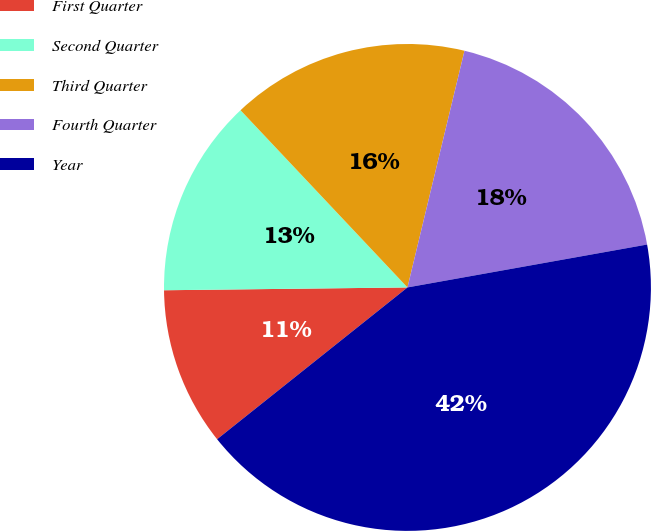<chart> <loc_0><loc_0><loc_500><loc_500><pie_chart><fcel>First Quarter<fcel>Second Quarter<fcel>Third Quarter<fcel>Fourth Quarter<fcel>Year<nl><fcel>10.53%<fcel>13.16%<fcel>15.79%<fcel>18.42%<fcel>42.11%<nl></chart> 